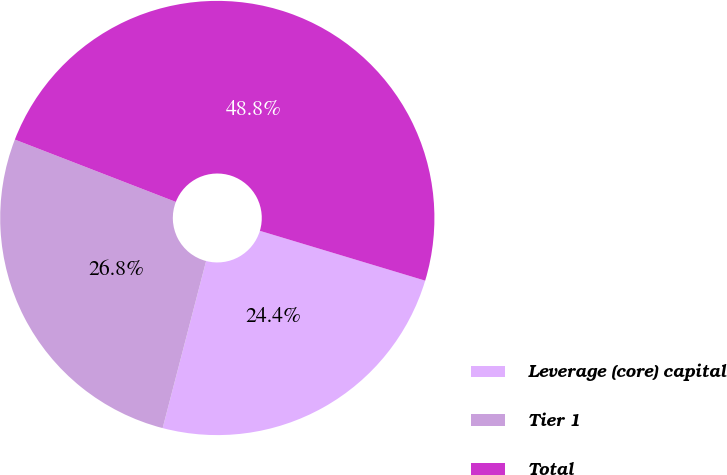<chart> <loc_0><loc_0><loc_500><loc_500><pie_chart><fcel>Leverage (core) capital<fcel>Tier 1<fcel>Total<nl><fcel>24.39%<fcel>26.83%<fcel>48.78%<nl></chart> 